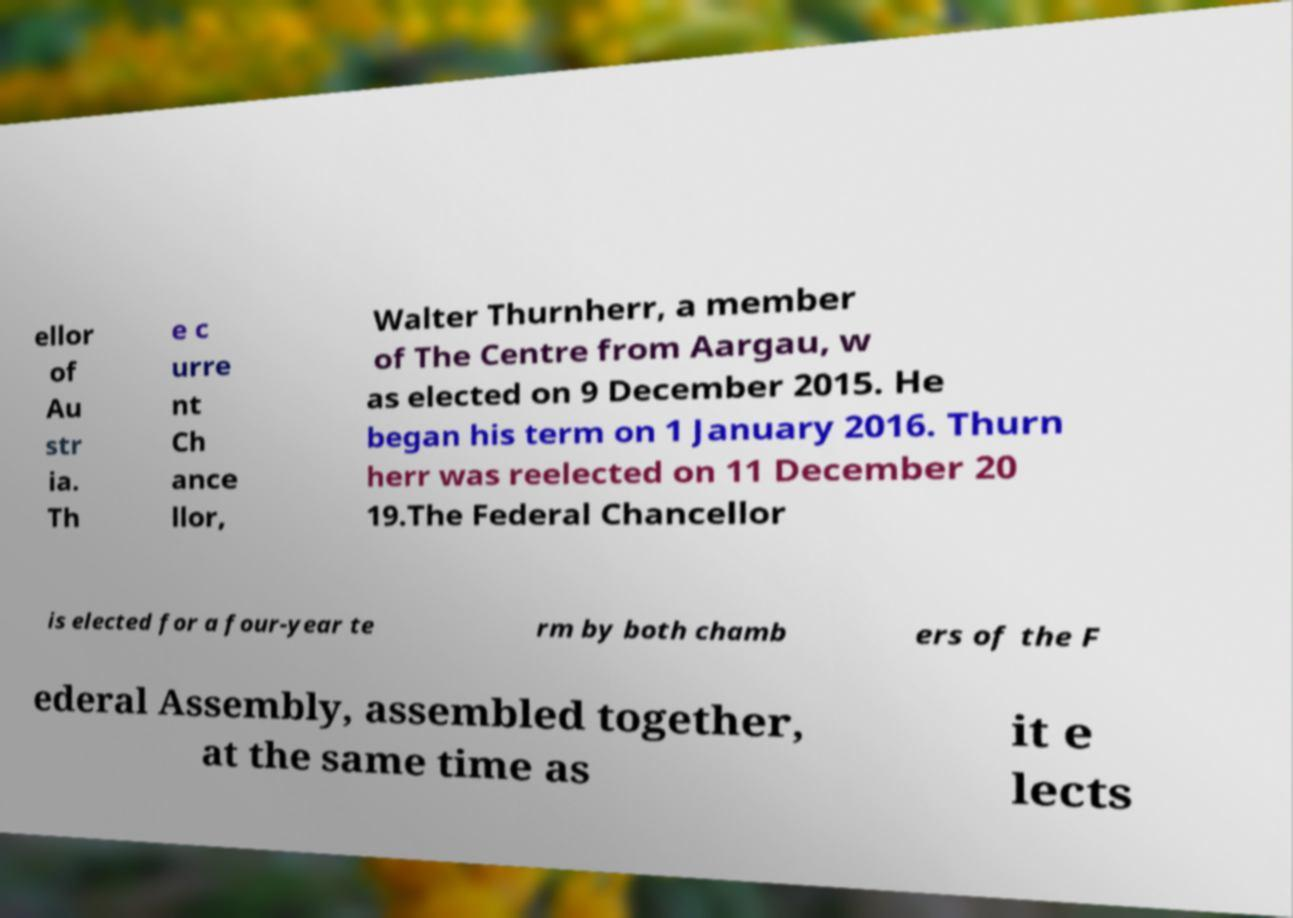Can you read and provide the text displayed in the image?This photo seems to have some interesting text. Can you extract and type it out for me? ellor of Au str ia. Th e c urre nt Ch ance llor, Walter Thurnherr, a member of The Centre from Aargau, w as elected on 9 December 2015. He began his term on 1 January 2016. Thurn herr was reelected on 11 December 20 19.The Federal Chancellor is elected for a four-year te rm by both chamb ers of the F ederal Assembly, assembled together, at the same time as it e lects 